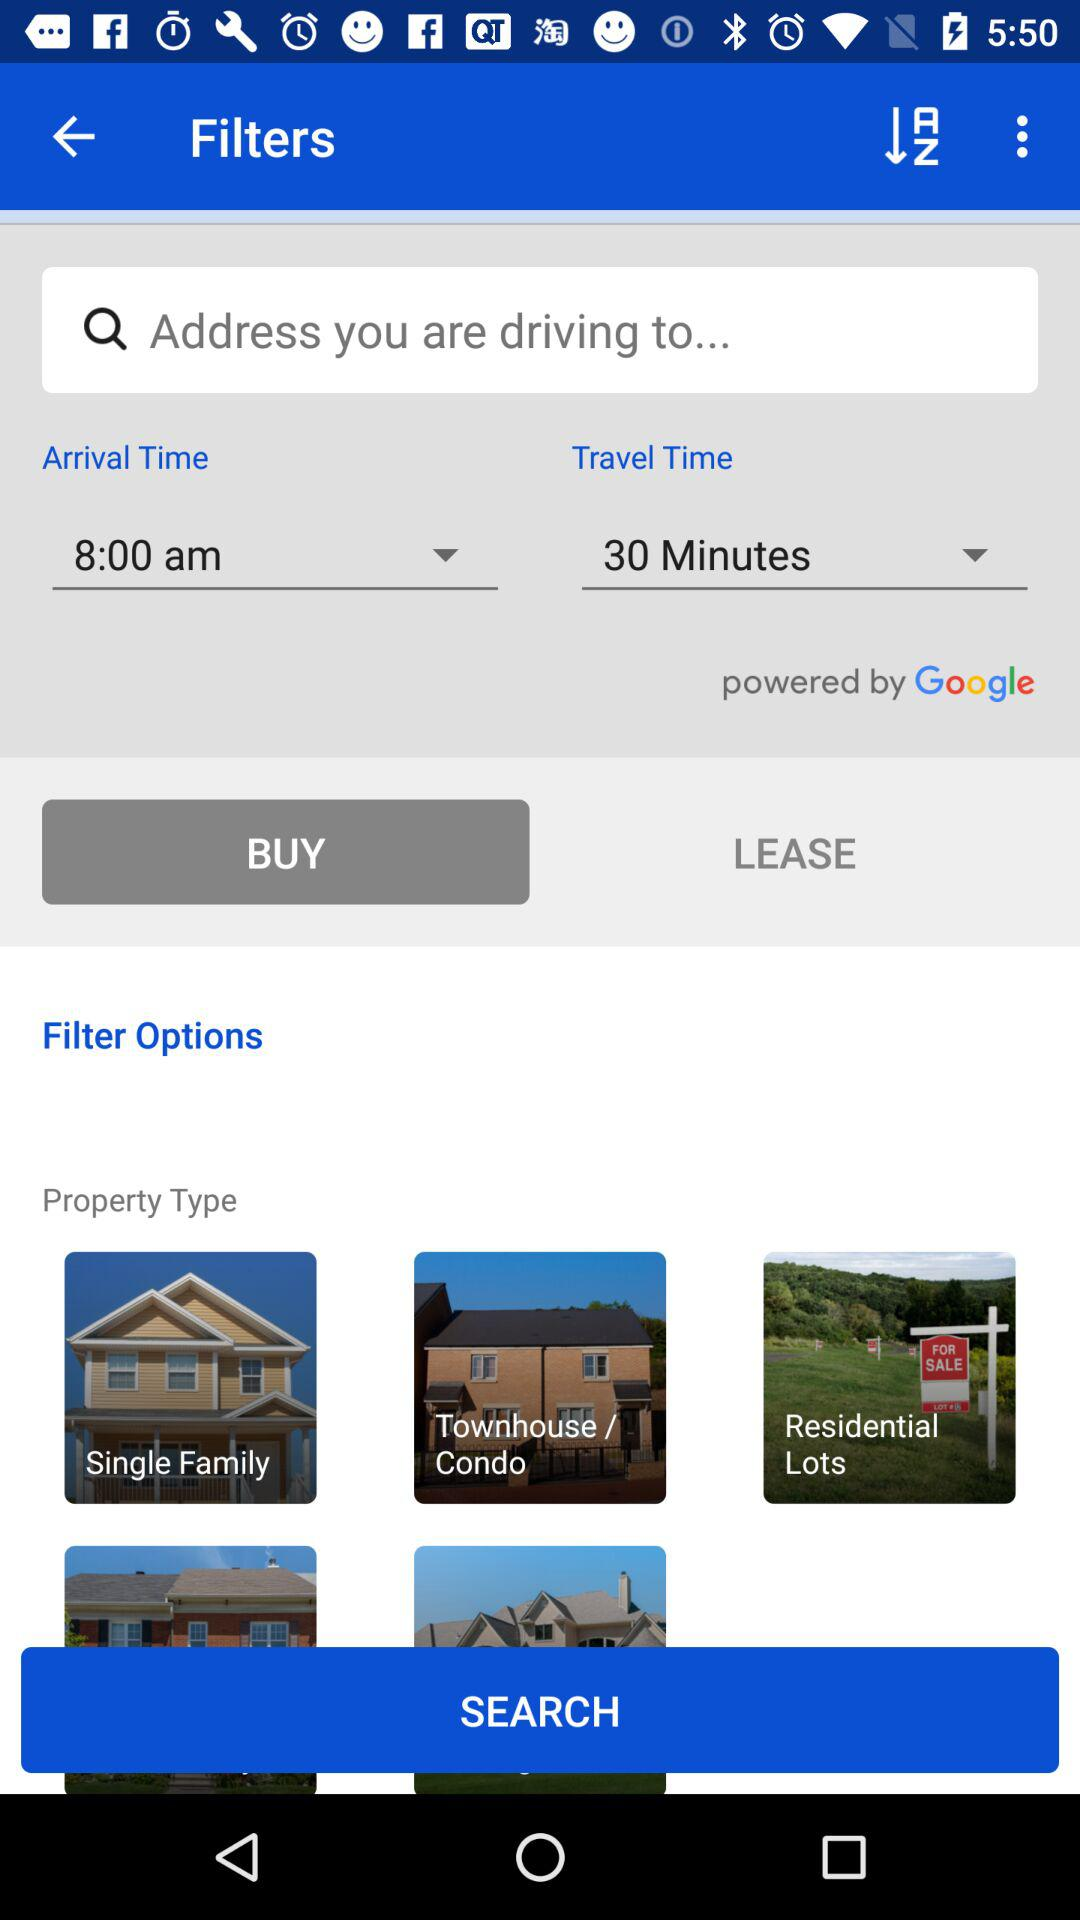How many more property types are there than filter options?
Answer the question using a single word or phrase. 2 